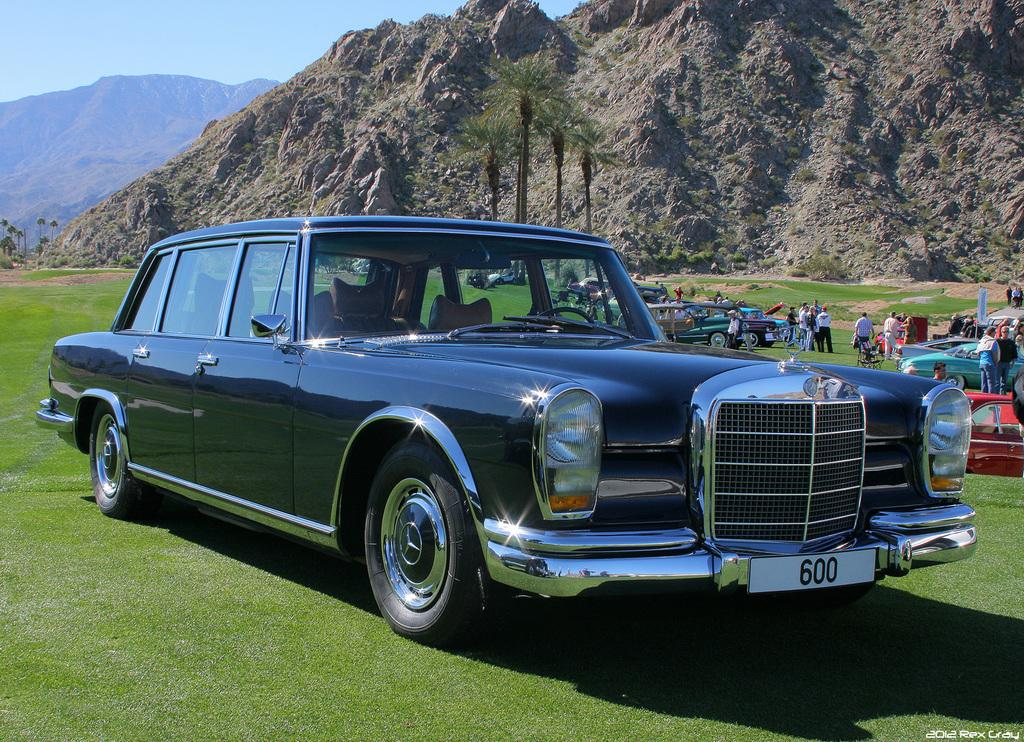What is the unusual location of the cars in the image? The cars are on the grass in the image. What can be seen in the background of the image? There is a group of people and trees in the background of the image. What type of landscape feature is visible in the background? There are hills visible in the background of the image. What is the name of the pet dog that is sitting next to the cars? There is no pet dog present in the image; only cars, grass, people, trees, and hills can be seen. 